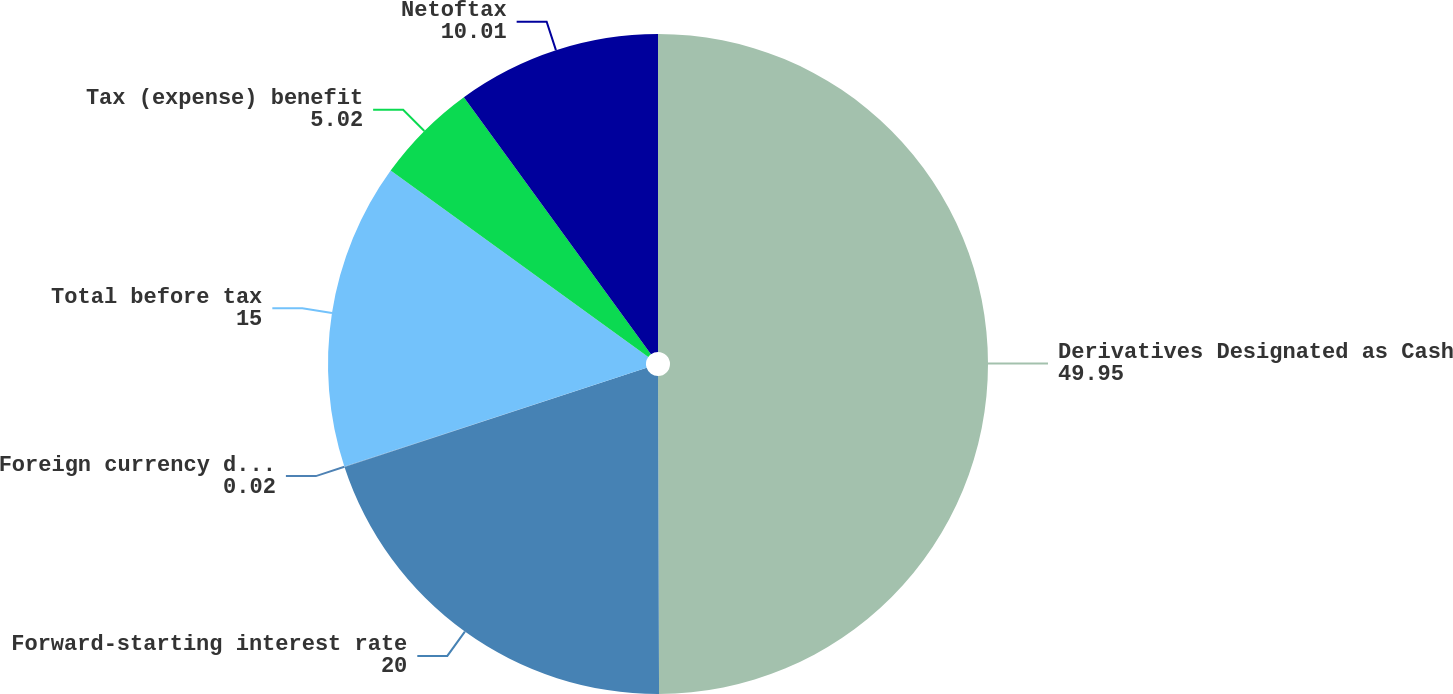Convert chart to OTSL. <chart><loc_0><loc_0><loc_500><loc_500><pie_chart><fcel>Derivatives Designated as Cash<fcel>Forward-starting interest rate<fcel>Foreign currency derivatives<fcel>Total before tax<fcel>Tax (expense) benefit<fcel>Netoftax<nl><fcel>49.95%<fcel>20.0%<fcel>0.02%<fcel>15.0%<fcel>5.02%<fcel>10.01%<nl></chart> 